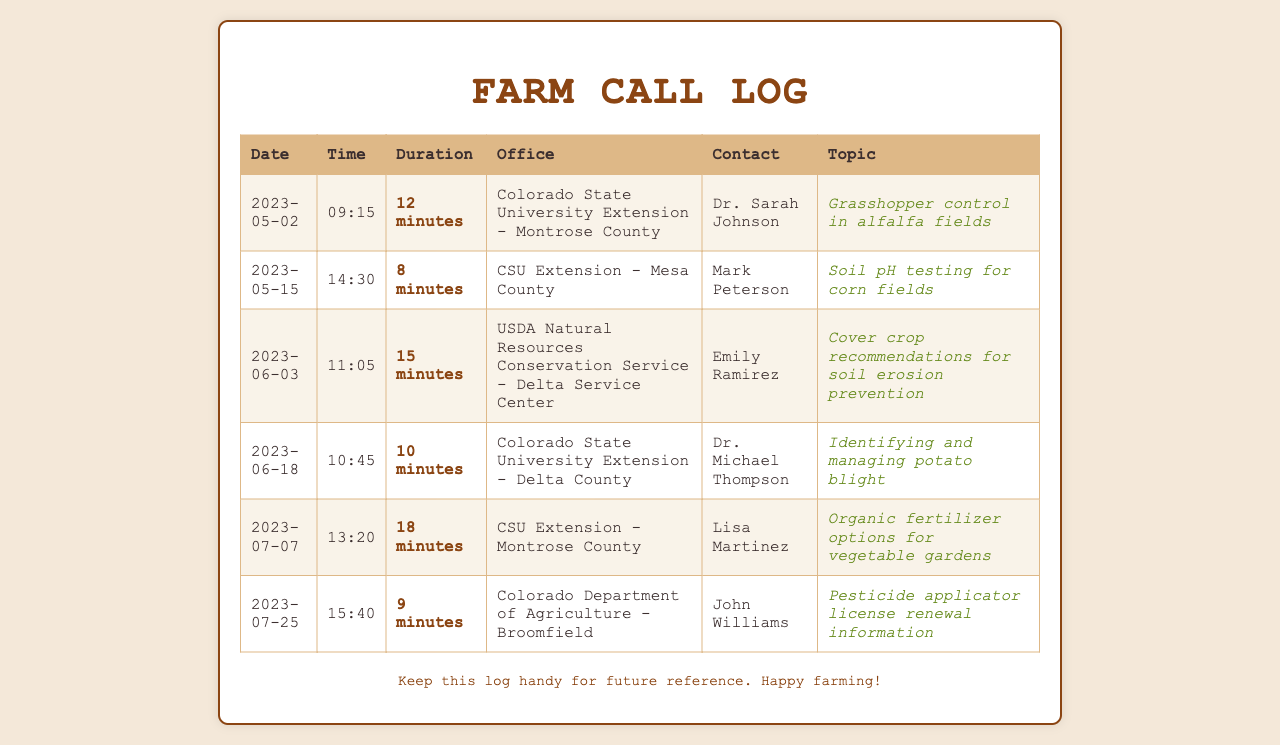what was the duration of the call with Dr. Sarah Johnson? The call with Dr. Sarah Johnson lasted for 12 minutes as listed in the call log.
Answer: 12 minutes who did you speak to regarding soil pH testing? The contact for soil pH testing inquiry was Mark Peterson from CSU Extension - Mesa County.
Answer: Mark Peterson on what date was the call about grasshopper control made? The grasshopper control call was made on May 2, 2023, according to the document.
Answer: 2023-05-02 which office provided recommendations for cover crops? The USDA Natural Resources Conservation Service - Delta Service Center offered recommendations for cover crops.
Answer: USDA Natural Resources Conservation Service - Delta Service Center how long did the call about pesticide applicator license renewal last? The call about pesticide applicator license renewal lasted for 9 minutes.
Answer: 9 minutes which topic had the longest call duration? The topic of organic fertilizer options for vegetable gardens had the longest call duration of 18 minutes.
Answer: Organic fertilizer options for vegetable gardens who was contacted for advice on identifying potato blight? Dr. Michael Thompson from Colorado State University Extension - Delta County was contacted for advice on identifying potato blight.
Answer: Dr. Michael Thompson which county did the call for organic fertilizer options take place? The organic fertilizer options call took place in Montrose County.
Answer: Montrose County 